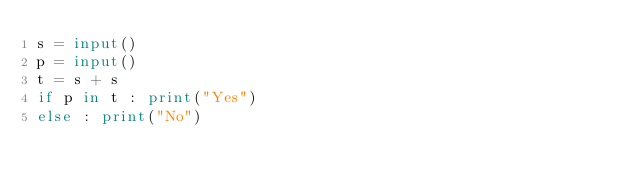<code> <loc_0><loc_0><loc_500><loc_500><_Python_>s = input()
p = input()
t = s + s
if p in t : print("Yes")
else : print("No")

</code> 